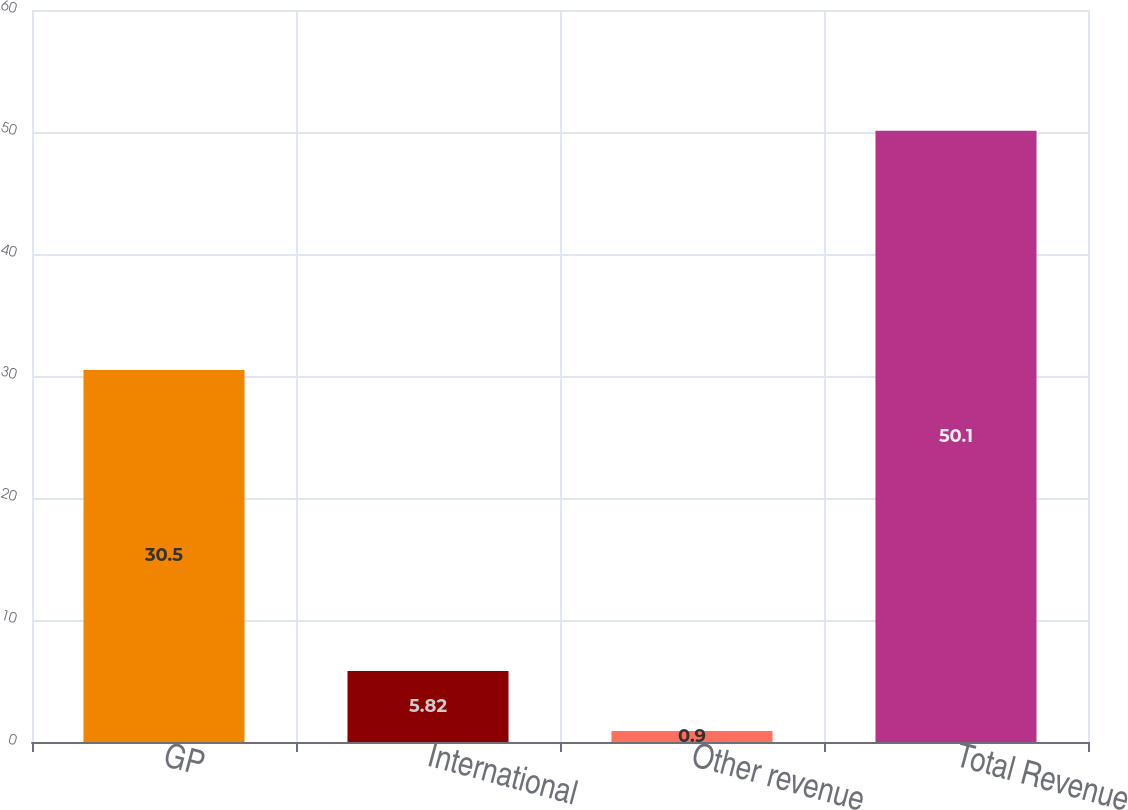Convert chart. <chart><loc_0><loc_0><loc_500><loc_500><bar_chart><fcel>GP<fcel>International<fcel>Other revenue<fcel>Total Revenue<nl><fcel>30.5<fcel>5.82<fcel>0.9<fcel>50.1<nl></chart> 